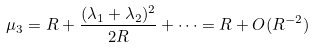Convert formula to latex. <formula><loc_0><loc_0><loc_500><loc_500>\mu _ { 3 } = R + \frac { ( \lambda _ { 1 } + \lambda _ { 2 } ) ^ { 2 } } { 2 R } + \dots = R + O ( R ^ { - 2 } )</formula> 